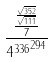Convert formula to latex. <formula><loc_0><loc_0><loc_500><loc_500>\frac { \frac { \frac { \sqrt { 3 5 2 } } { \sqrt { 1 1 1 } } } { 7 } } { { 4 ^ { 3 3 6 } } ^ { 2 9 4 } }</formula> 